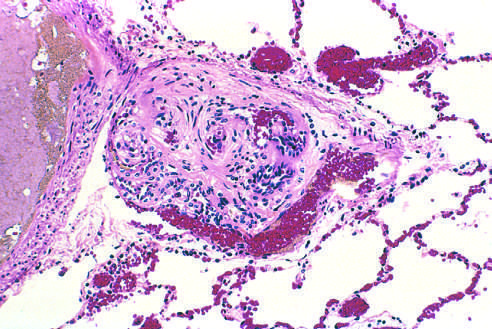where is plexiform lesion characteristic of advanced pulmonary hypertension seen?
Answer the question using a single word or phrase. In small arteries 